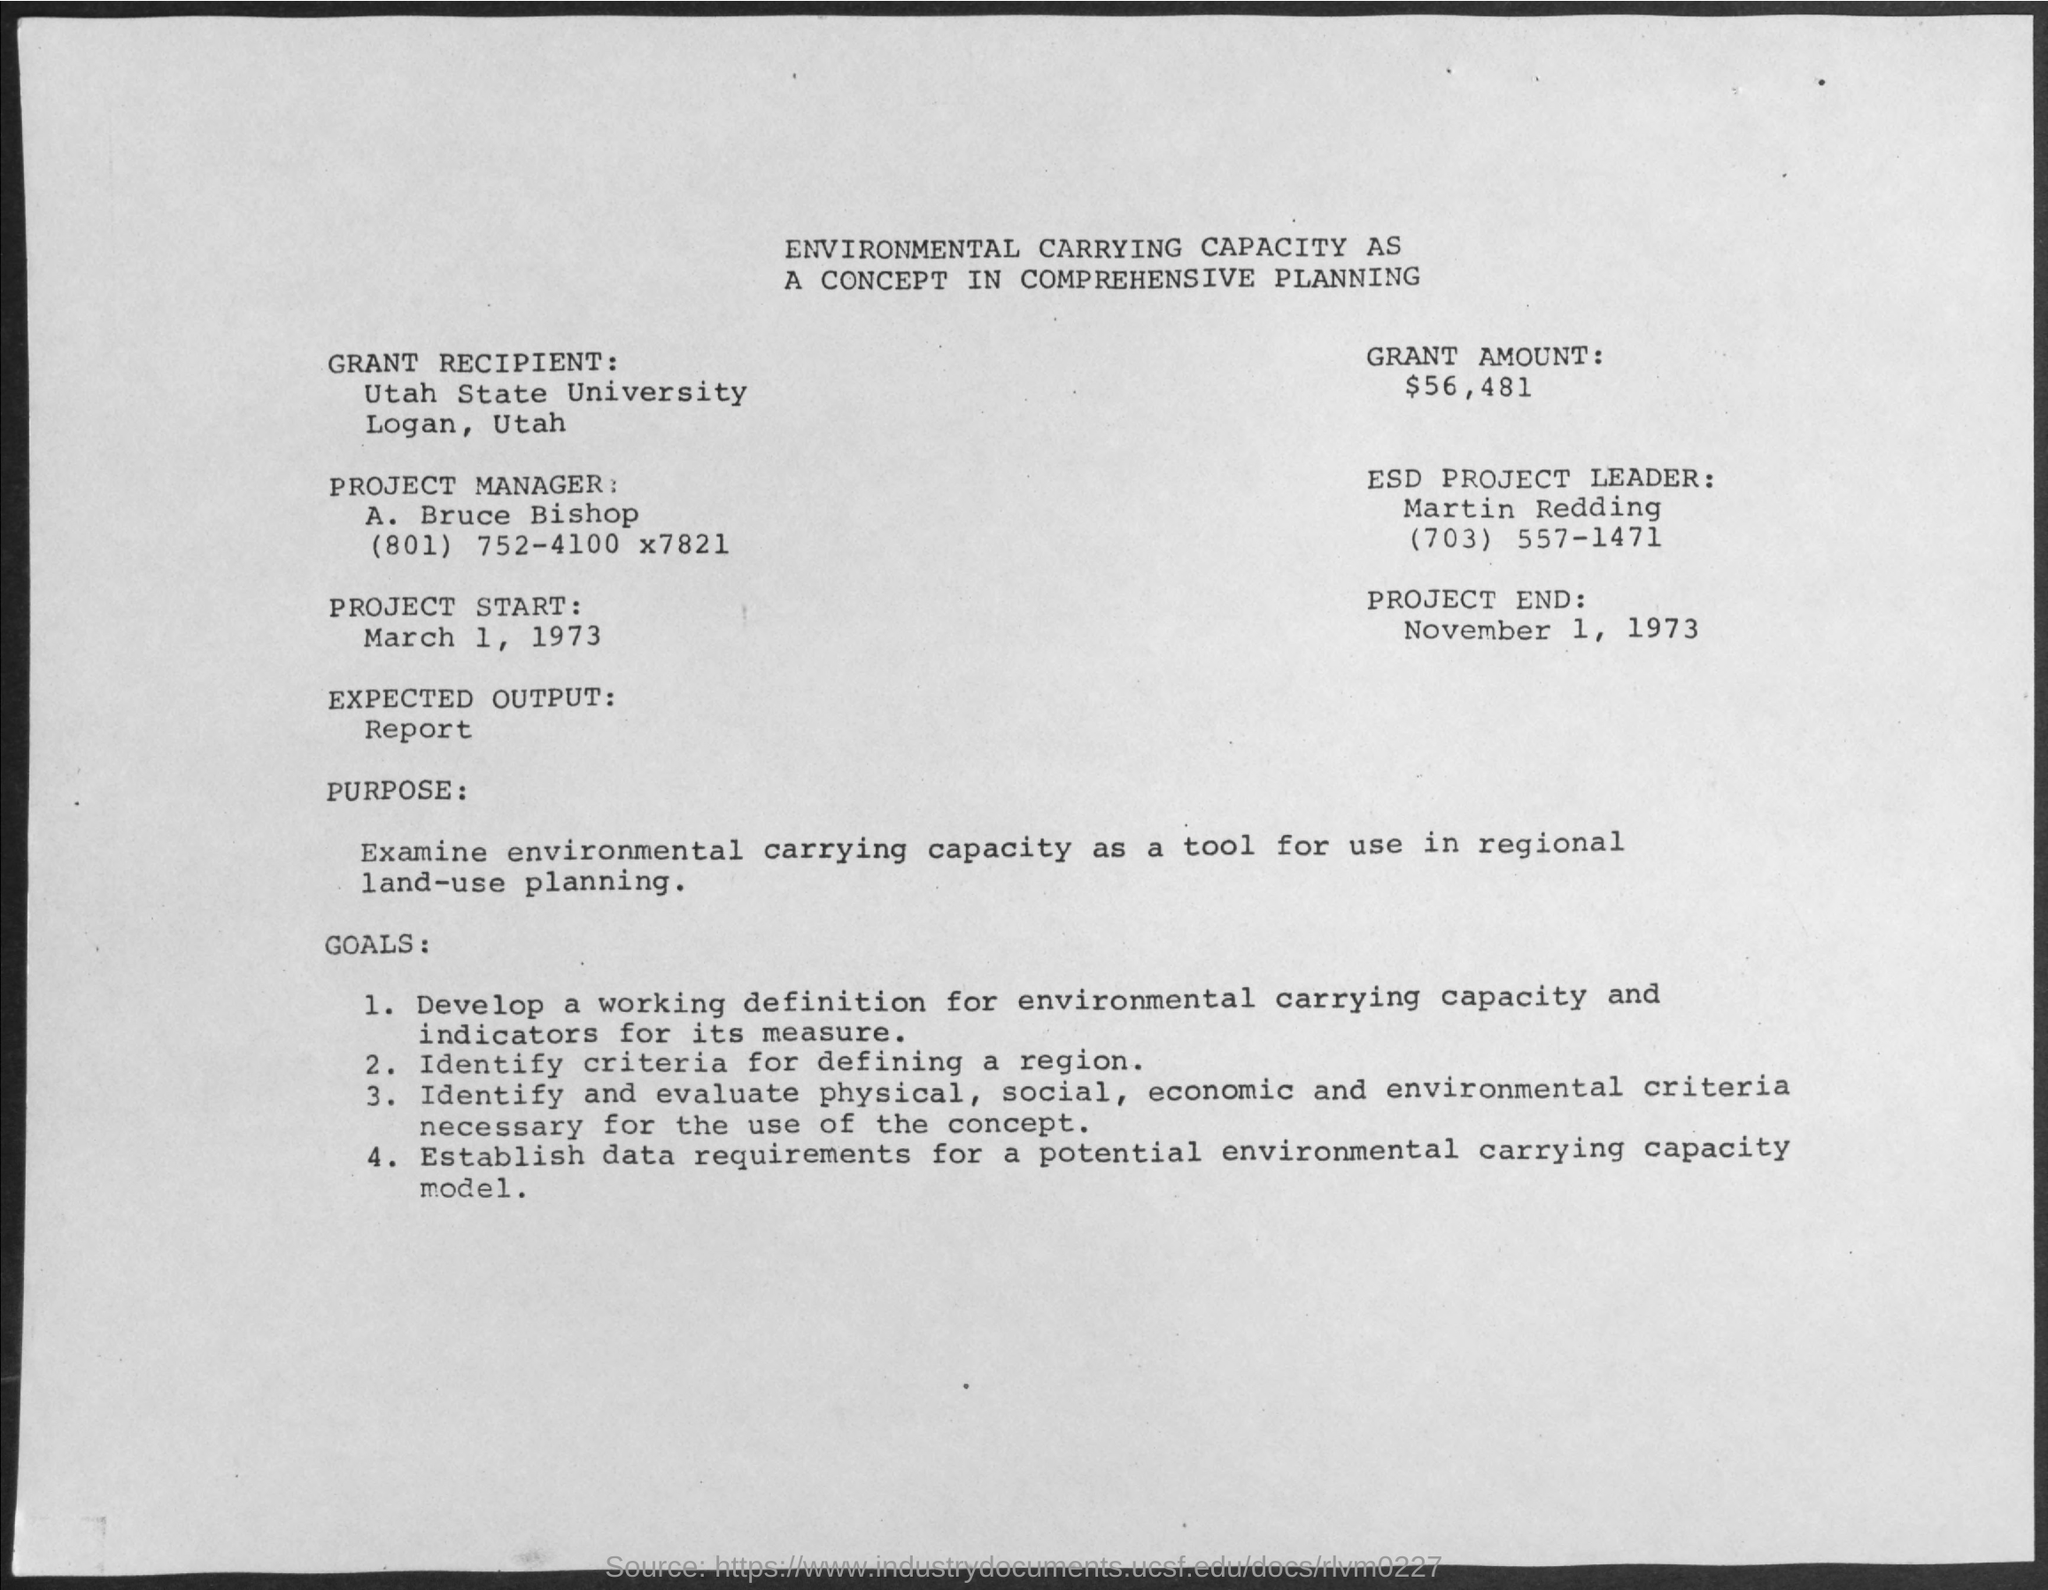Indicate a few pertinent items in this graphic. The project is scheduled to end on November 1, 1973. The project began on March 1, 1973. Utah State University is the grant recipient. The grant amount is $56,481. The project manager is Bruce Bishop, who may be reached at (801) 752-4100 extension 7821. 